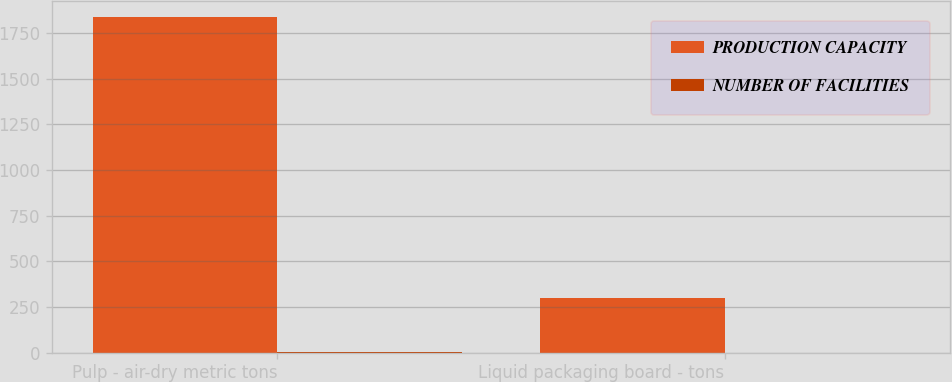<chart> <loc_0><loc_0><loc_500><loc_500><stacked_bar_chart><ecel><fcel>Pulp - air-dry metric tons<fcel>Liquid packaging board - tons<nl><fcel>PRODUCTION CAPACITY<fcel>1835<fcel>300<nl><fcel>NUMBER OF FACILITIES<fcel>5<fcel>1<nl></chart> 